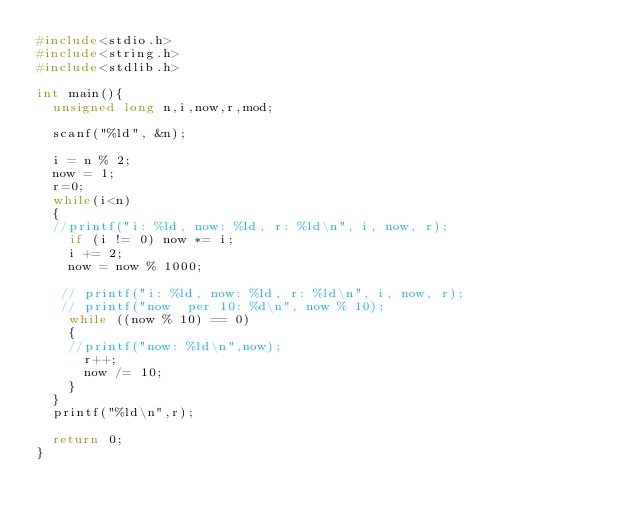<code> <loc_0><loc_0><loc_500><loc_500><_C_>#include<stdio.h>
#include<string.h>
#include<stdlib.h>

int main(){
  unsigned long n,i,now,r,mod;

  scanf("%ld", &n);

  i = n % 2;
  now = 1;
  r=0;
  while(i<n)
  {
  //printf("i: %ld, now: %ld, r: %ld\n", i, now, r);
    if (i != 0) now *= i;
    i += 2;
    now = now % 1000;

   // printf("i: %ld, now: %ld, r: %ld\n", i, now, r);
   // printf("now  per 10: %d\n", now % 10);
    while ((now % 10) == 0)
    {
    //printf("now: %ld\n",now);
      r++;
      now /= 10;
    }
  }
  printf("%ld\n",r);

  return 0;
}</code> 